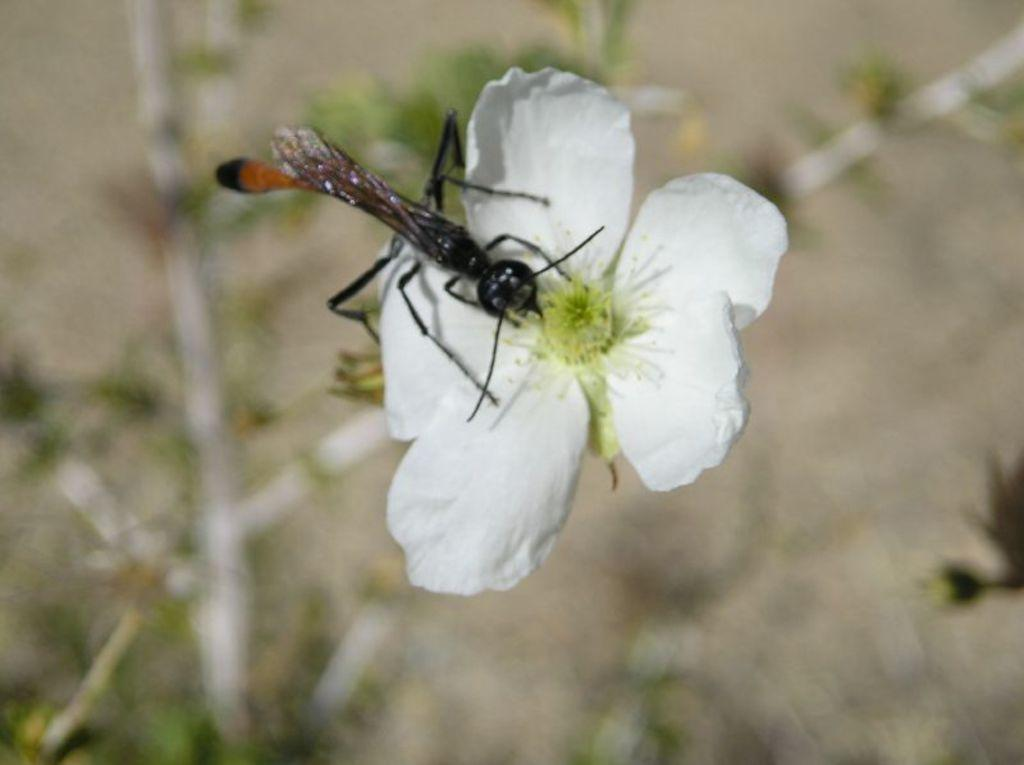What type of flower is in the image? There is a white color flower in the image. Is there anything on the flower? Yes, there is a sawfly on the flower. Can you describe the background of the image? The background of the image is blurry. What type of lamp is hanging above the flower in the image? There is no lamp present in the image; it only features a white color flower and a sawfly. 